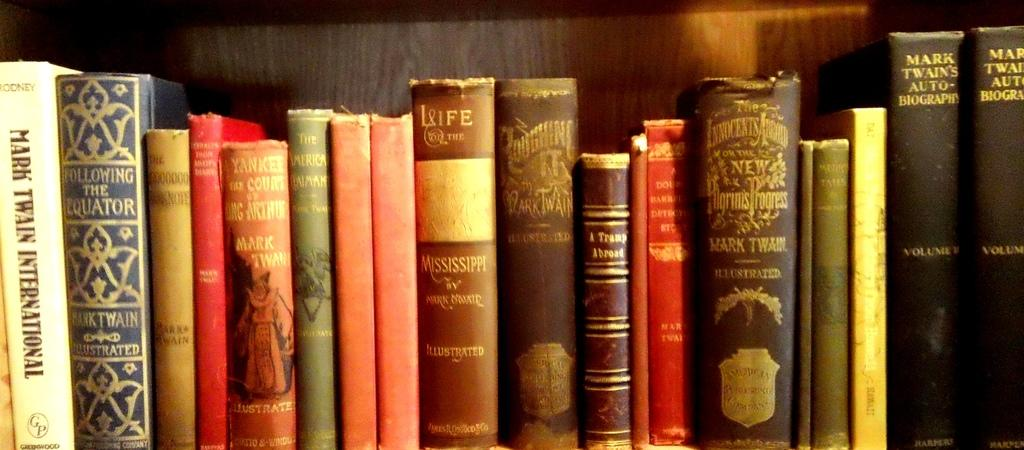<image>
Offer a succinct explanation of the picture presented. a Mark Twain book that is on a shelf 